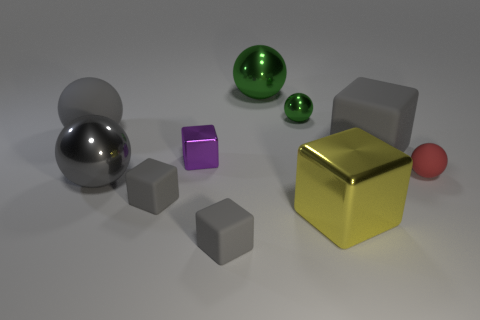Subtract all gray blocks. How many were subtracted if there are1gray blocks left? 2 Subtract all gray matte spheres. How many spheres are left? 4 Subtract all red balls. How many balls are left? 4 Subtract 4 blocks. How many blocks are left? 1 Subtract all green balls. Subtract all red cubes. How many balls are left? 3 Subtract all green cylinders. How many gray cubes are left? 3 Subtract 0 cyan cubes. How many objects are left? 10 Subtract all blue matte blocks. Subtract all gray spheres. How many objects are left? 8 Add 7 tiny matte things. How many tiny matte things are left? 10 Add 2 large rubber objects. How many large rubber objects exist? 4 